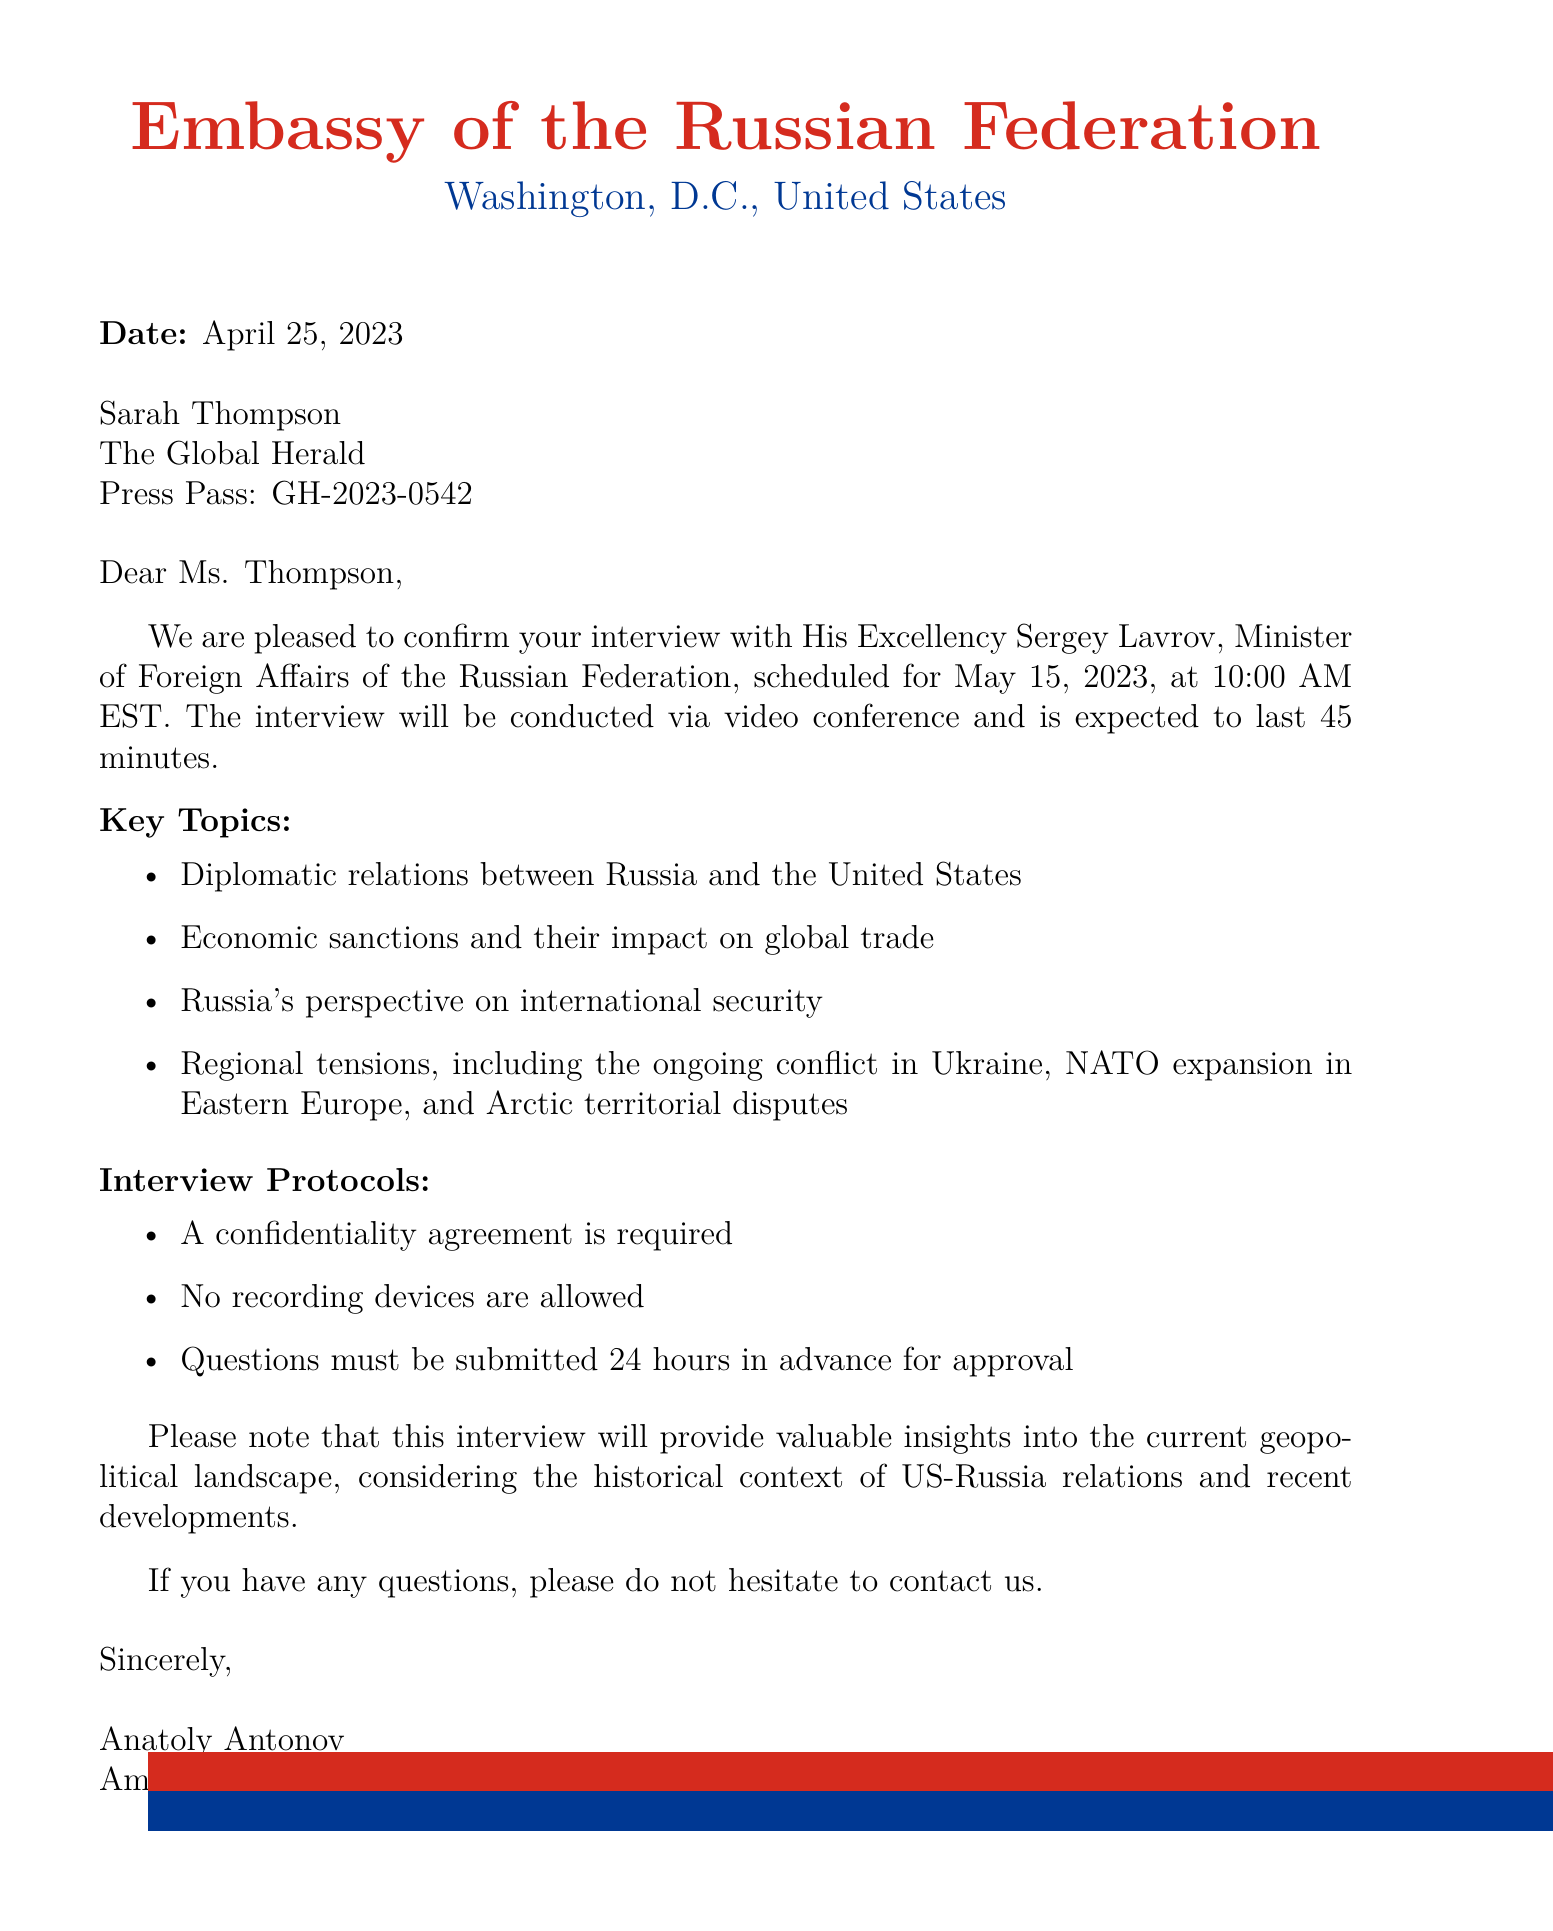what is the name of the embassy? The name of the embassy is stated in the document as "Embassy of the Russian Federation."
Answer: Embassy of the Russian Federation who is the contact person? The document specifies the contact person as Anatoly Antonov.
Answer: Anatoly Antonov when is the interview scheduled? The interview date is explicitly mentioned in the document, which is May 15, 2023.
Answer: May 15, 2023 how long will the interview last? The expected duration of the interview is stated as 45 minutes.
Answer: 45 minutes what is one key topic of the interview? The document lists several key topics, one of which is "Diplomatic relations between Russia and the United States."
Answer: Diplomatic relations between Russia and the United States what are the security protocols for the interview? The document outlines multiple security protocols, including a confidentiality agreement requirement.
Answer: Confidentiality agreement required what historical context is mentioned regarding US-Russia relations? The document mentions the "Cold War legacy" as a part of the historical context.
Answer: Cold War legacy what is the interview format? The document specifies that the interview will be conducted via video conference.
Answer: Video conference 